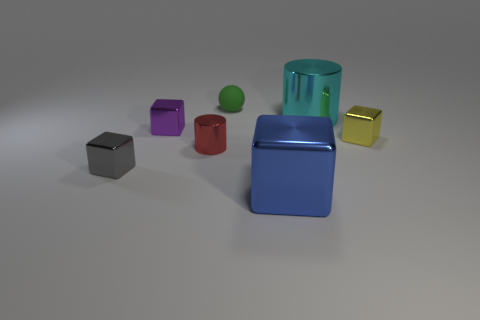Subtract 1 blocks. How many blocks are left? 3 Add 2 tiny brown matte things. How many objects exist? 9 Subtract all balls. How many objects are left? 6 Subtract all tiny things. Subtract all tiny red shiny objects. How many objects are left? 1 Add 3 tiny gray objects. How many tiny gray objects are left? 4 Add 6 red cylinders. How many red cylinders exist? 7 Subtract 0 blue cylinders. How many objects are left? 7 